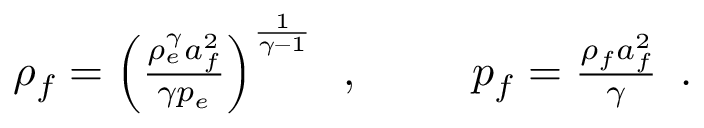<formula> <loc_0><loc_0><loc_500><loc_500>\begin{array} { r l r } { \rho _ { f } = \left ( \frac { \rho _ { e } ^ { \gamma } a _ { f } ^ { 2 } } { \gamma p _ { e } } \right ) ^ { \frac { 1 } { \gamma - 1 } } \, , } & \ } & { p _ { f } = \frac { \rho _ { f } a _ { f } ^ { 2 } } { \gamma } \, . } \end{array}</formula> 